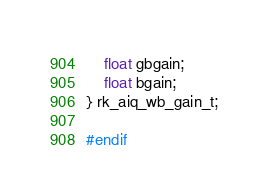<code> <loc_0><loc_0><loc_500><loc_500><_C_>    float gbgain;
    float bgain;
} rk_aiq_wb_gain_t;

#endif


</code> 